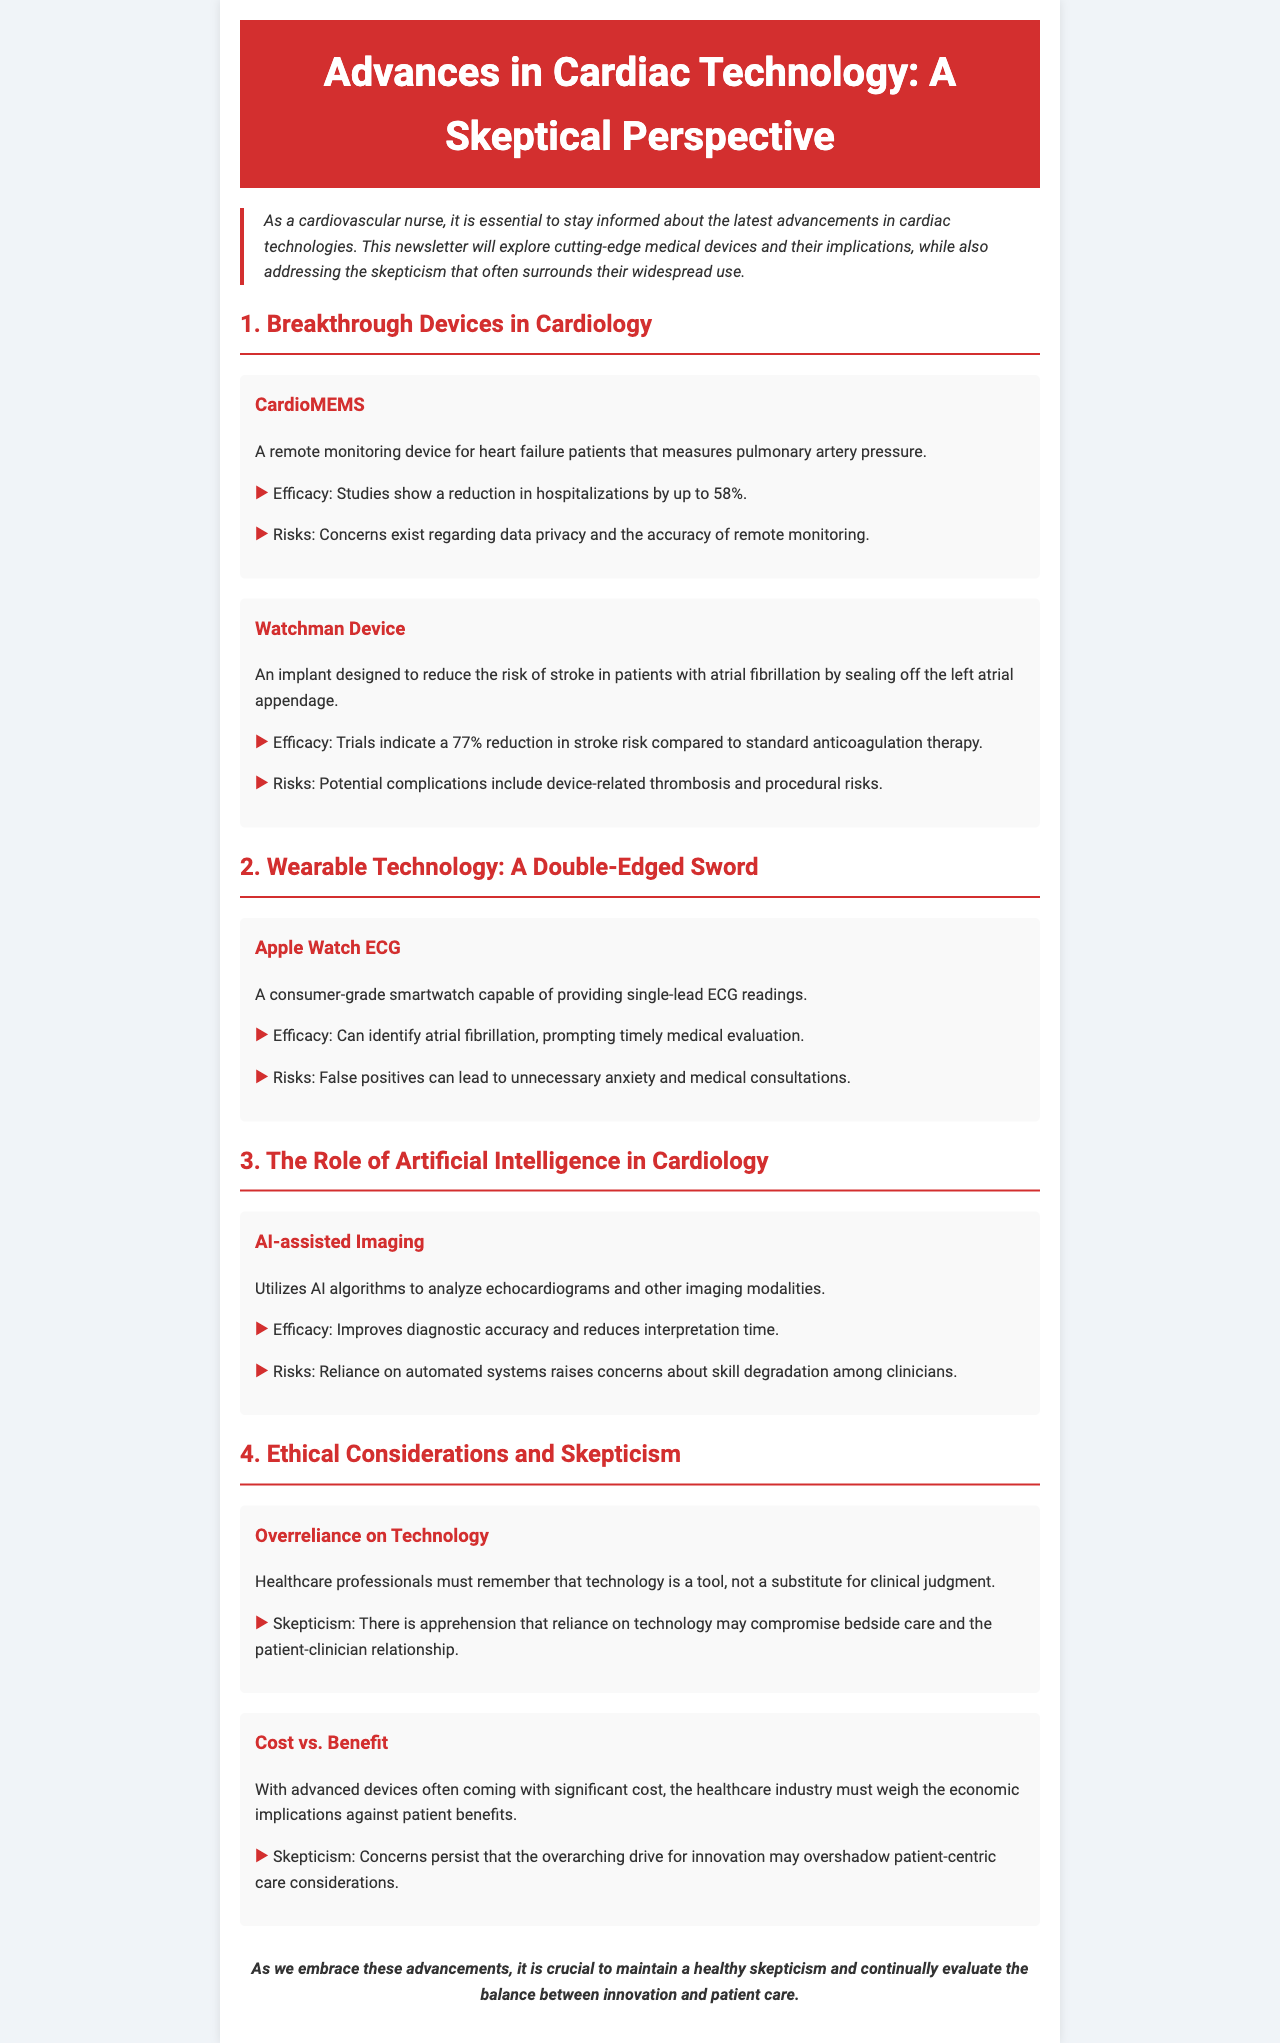what is the title of the newsletter? The title is provided in the header section of the document.
Answer: Advances in Cardiac Technology: A Skeptical Perspective what device measures pulmonary artery pressure? The document lists a specific device under the section for breakthrough devices in cardiology.
Answer: CardioMEMS how much hospitalizations can CardioMEMS reduce? The document states a specific percentage reduction attributed to CardioMEMS.
Answer: 58% what is the percentage reduction in stroke risk by the Watchman Device? The document indicates a specific percentage related to the efficacy of the Watchman Device in trials.
Answer: 77% what ethical concern is mentioned regarding overreliance on technology? The document highlights a particular skepticism related to technology use in healthcare.
Answer: Compromise bedside care what potential risk is associated with the Apple Watch ECG? The document lists a specific risk concerning the use of the Apple Watch for ECG readings.
Answer: False positives what type of AI application is discussed in the newsletter? The document describes a specific use of AI in cardiology under the AI section.
Answer: AI-assisted Imaging what is the main critique addressed under cost vs. benefit? The document discusses a particular concern regarding the economic implications of advanced devices.
Answer: Patient-centric care considerations 